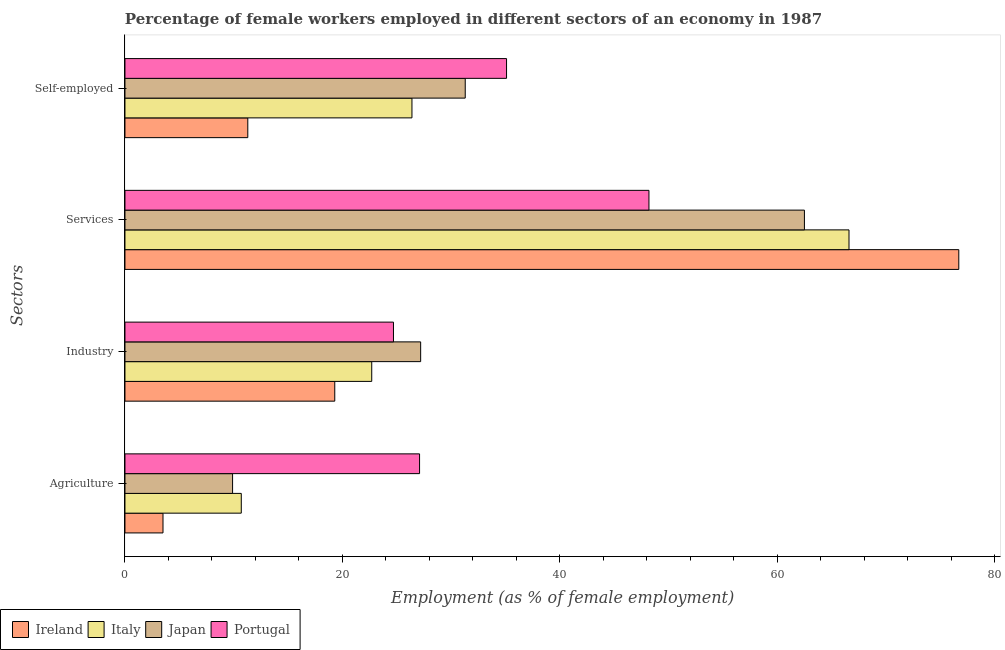Are the number of bars on each tick of the Y-axis equal?
Offer a very short reply. Yes. How many bars are there on the 1st tick from the top?
Keep it short and to the point. 4. What is the label of the 2nd group of bars from the top?
Offer a very short reply. Services. What is the percentage of female workers in agriculture in Japan?
Your answer should be compact. 9.9. Across all countries, what is the maximum percentage of female workers in services?
Ensure brevity in your answer.  76.7. Across all countries, what is the minimum percentage of female workers in agriculture?
Keep it short and to the point. 3.5. In which country was the percentage of self employed female workers minimum?
Ensure brevity in your answer.  Ireland. What is the total percentage of female workers in services in the graph?
Offer a very short reply. 254. What is the difference between the percentage of female workers in services in Ireland and that in Italy?
Your answer should be compact. 10.1. What is the difference between the percentage of female workers in industry in Ireland and the percentage of female workers in agriculture in Japan?
Make the answer very short. 9.4. What is the average percentage of female workers in agriculture per country?
Ensure brevity in your answer.  12.8. What is the difference between the percentage of self employed female workers and percentage of female workers in services in Japan?
Give a very brief answer. -31.2. What is the ratio of the percentage of self employed female workers in Italy to that in Ireland?
Your response must be concise. 2.34. Is the difference between the percentage of female workers in services in Japan and Ireland greater than the difference between the percentage of self employed female workers in Japan and Ireland?
Your answer should be compact. No. What is the difference between the highest and the second highest percentage of self employed female workers?
Ensure brevity in your answer.  3.8. What is the difference between the highest and the lowest percentage of female workers in agriculture?
Offer a very short reply. 23.6. What does the 2nd bar from the top in Self-employed represents?
Provide a short and direct response. Japan. What does the 2nd bar from the bottom in Industry represents?
Offer a terse response. Italy. Is it the case that in every country, the sum of the percentage of female workers in agriculture and percentage of female workers in industry is greater than the percentage of female workers in services?
Offer a very short reply. No. How many bars are there?
Your response must be concise. 16. Are the values on the major ticks of X-axis written in scientific E-notation?
Keep it short and to the point. No. Where does the legend appear in the graph?
Provide a short and direct response. Bottom left. How many legend labels are there?
Your answer should be compact. 4. How are the legend labels stacked?
Provide a succinct answer. Horizontal. What is the title of the graph?
Your response must be concise. Percentage of female workers employed in different sectors of an economy in 1987. What is the label or title of the X-axis?
Keep it short and to the point. Employment (as % of female employment). What is the label or title of the Y-axis?
Your answer should be compact. Sectors. What is the Employment (as % of female employment) of Italy in Agriculture?
Give a very brief answer. 10.7. What is the Employment (as % of female employment) of Japan in Agriculture?
Your answer should be very brief. 9.9. What is the Employment (as % of female employment) of Portugal in Agriculture?
Your answer should be very brief. 27.1. What is the Employment (as % of female employment) in Ireland in Industry?
Offer a very short reply. 19.3. What is the Employment (as % of female employment) of Italy in Industry?
Give a very brief answer. 22.7. What is the Employment (as % of female employment) of Japan in Industry?
Your answer should be compact. 27.2. What is the Employment (as % of female employment) of Portugal in Industry?
Your response must be concise. 24.7. What is the Employment (as % of female employment) of Ireland in Services?
Provide a succinct answer. 76.7. What is the Employment (as % of female employment) in Italy in Services?
Keep it short and to the point. 66.6. What is the Employment (as % of female employment) of Japan in Services?
Provide a succinct answer. 62.5. What is the Employment (as % of female employment) of Portugal in Services?
Make the answer very short. 48.2. What is the Employment (as % of female employment) in Ireland in Self-employed?
Make the answer very short. 11.3. What is the Employment (as % of female employment) in Italy in Self-employed?
Your answer should be compact. 26.4. What is the Employment (as % of female employment) in Japan in Self-employed?
Your answer should be very brief. 31.3. What is the Employment (as % of female employment) of Portugal in Self-employed?
Provide a succinct answer. 35.1. Across all Sectors, what is the maximum Employment (as % of female employment) in Ireland?
Your answer should be compact. 76.7. Across all Sectors, what is the maximum Employment (as % of female employment) of Italy?
Your answer should be very brief. 66.6. Across all Sectors, what is the maximum Employment (as % of female employment) of Japan?
Your response must be concise. 62.5. Across all Sectors, what is the maximum Employment (as % of female employment) in Portugal?
Keep it short and to the point. 48.2. Across all Sectors, what is the minimum Employment (as % of female employment) in Italy?
Your answer should be very brief. 10.7. Across all Sectors, what is the minimum Employment (as % of female employment) in Japan?
Provide a succinct answer. 9.9. Across all Sectors, what is the minimum Employment (as % of female employment) in Portugal?
Provide a short and direct response. 24.7. What is the total Employment (as % of female employment) in Ireland in the graph?
Keep it short and to the point. 110.8. What is the total Employment (as % of female employment) of Italy in the graph?
Offer a terse response. 126.4. What is the total Employment (as % of female employment) in Japan in the graph?
Offer a very short reply. 130.9. What is the total Employment (as % of female employment) in Portugal in the graph?
Give a very brief answer. 135.1. What is the difference between the Employment (as % of female employment) in Ireland in Agriculture and that in Industry?
Your response must be concise. -15.8. What is the difference between the Employment (as % of female employment) of Italy in Agriculture and that in Industry?
Keep it short and to the point. -12. What is the difference between the Employment (as % of female employment) in Japan in Agriculture and that in Industry?
Offer a terse response. -17.3. What is the difference between the Employment (as % of female employment) in Ireland in Agriculture and that in Services?
Keep it short and to the point. -73.2. What is the difference between the Employment (as % of female employment) of Italy in Agriculture and that in Services?
Ensure brevity in your answer.  -55.9. What is the difference between the Employment (as % of female employment) in Japan in Agriculture and that in Services?
Your answer should be very brief. -52.6. What is the difference between the Employment (as % of female employment) of Portugal in Agriculture and that in Services?
Offer a terse response. -21.1. What is the difference between the Employment (as % of female employment) in Italy in Agriculture and that in Self-employed?
Ensure brevity in your answer.  -15.7. What is the difference between the Employment (as % of female employment) in Japan in Agriculture and that in Self-employed?
Give a very brief answer. -21.4. What is the difference between the Employment (as % of female employment) of Portugal in Agriculture and that in Self-employed?
Your response must be concise. -8. What is the difference between the Employment (as % of female employment) of Ireland in Industry and that in Services?
Offer a terse response. -57.4. What is the difference between the Employment (as % of female employment) of Italy in Industry and that in Services?
Give a very brief answer. -43.9. What is the difference between the Employment (as % of female employment) in Japan in Industry and that in Services?
Provide a succinct answer. -35.3. What is the difference between the Employment (as % of female employment) of Portugal in Industry and that in Services?
Ensure brevity in your answer.  -23.5. What is the difference between the Employment (as % of female employment) of Japan in Industry and that in Self-employed?
Offer a very short reply. -4.1. What is the difference between the Employment (as % of female employment) of Ireland in Services and that in Self-employed?
Your answer should be compact. 65.4. What is the difference between the Employment (as % of female employment) in Italy in Services and that in Self-employed?
Make the answer very short. 40.2. What is the difference between the Employment (as % of female employment) in Japan in Services and that in Self-employed?
Your response must be concise. 31.2. What is the difference between the Employment (as % of female employment) of Portugal in Services and that in Self-employed?
Give a very brief answer. 13.1. What is the difference between the Employment (as % of female employment) in Ireland in Agriculture and the Employment (as % of female employment) in Italy in Industry?
Provide a succinct answer. -19.2. What is the difference between the Employment (as % of female employment) of Ireland in Agriculture and the Employment (as % of female employment) of Japan in Industry?
Give a very brief answer. -23.7. What is the difference between the Employment (as % of female employment) of Ireland in Agriculture and the Employment (as % of female employment) of Portugal in Industry?
Keep it short and to the point. -21.2. What is the difference between the Employment (as % of female employment) in Italy in Agriculture and the Employment (as % of female employment) in Japan in Industry?
Offer a terse response. -16.5. What is the difference between the Employment (as % of female employment) of Japan in Agriculture and the Employment (as % of female employment) of Portugal in Industry?
Give a very brief answer. -14.8. What is the difference between the Employment (as % of female employment) in Ireland in Agriculture and the Employment (as % of female employment) in Italy in Services?
Your response must be concise. -63.1. What is the difference between the Employment (as % of female employment) in Ireland in Agriculture and the Employment (as % of female employment) in Japan in Services?
Your response must be concise. -59. What is the difference between the Employment (as % of female employment) in Ireland in Agriculture and the Employment (as % of female employment) in Portugal in Services?
Your response must be concise. -44.7. What is the difference between the Employment (as % of female employment) in Italy in Agriculture and the Employment (as % of female employment) in Japan in Services?
Provide a succinct answer. -51.8. What is the difference between the Employment (as % of female employment) in Italy in Agriculture and the Employment (as % of female employment) in Portugal in Services?
Your response must be concise. -37.5. What is the difference between the Employment (as % of female employment) in Japan in Agriculture and the Employment (as % of female employment) in Portugal in Services?
Your answer should be compact. -38.3. What is the difference between the Employment (as % of female employment) of Ireland in Agriculture and the Employment (as % of female employment) of Italy in Self-employed?
Provide a succinct answer. -22.9. What is the difference between the Employment (as % of female employment) of Ireland in Agriculture and the Employment (as % of female employment) of Japan in Self-employed?
Your answer should be very brief. -27.8. What is the difference between the Employment (as % of female employment) of Ireland in Agriculture and the Employment (as % of female employment) of Portugal in Self-employed?
Offer a very short reply. -31.6. What is the difference between the Employment (as % of female employment) in Italy in Agriculture and the Employment (as % of female employment) in Japan in Self-employed?
Offer a terse response. -20.6. What is the difference between the Employment (as % of female employment) in Italy in Agriculture and the Employment (as % of female employment) in Portugal in Self-employed?
Your response must be concise. -24.4. What is the difference between the Employment (as % of female employment) of Japan in Agriculture and the Employment (as % of female employment) of Portugal in Self-employed?
Provide a succinct answer. -25.2. What is the difference between the Employment (as % of female employment) of Ireland in Industry and the Employment (as % of female employment) of Italy in Services?
Ensure brevity in your answer.  -47.3. What is the difference between the Employment (as % of female employment) in Ireland in Industry and the Employment (as % of female employment) in Japan in Services?
Offer a terse response. -43.2. What is the difference between the Employment (as % of female employment) of Ireland in Industry and the Employment (as % of female employment) of Portugal in Services?
Your answer should be compact. -28.9. What is the difference between the Employment (as % of female employment) in Italy in Industry and the Employment (as % of female employment) in Japan in Services?
Keep it short and to the point. -39.8. What is the difference between the Employment (as % of female employment) in Italy in Industry and the Employment (as % of female employment) in Portugal in Services?
Keep it short and to the point. -25.5. What is the difference between the Employment (as % of female employment) in Ireland in Industry and the Employment (as % of female employment) in Portugal in Self-employed?
Offer a terse response. -15.8. What is the difference between the Employment (as % of female employment) in Italy in Industry and the Employment (as % of female employment) in Portugal in Self-employed?
Your response must be concise. -12.4. What is the difference between the Employment (as % of female employment) of Ireland in Services and the Employment (as % of female employment) of Italy in Self-employed?
Your answer should be compact. 50.3. What is the difference between the Employment (as % of female employment) of Ireland in Services and the Employment (as % of female employment) of Japan in Self-employed?
Provide a succinct answer. 45.4. What is the difference between the Employment (as % of female employment) in Ireland in Services and the Employment (as % of female employment) in Portugal in Self-employed?
Ensure brevity in your answer.  41.6. What is the difference between the Employment (as % of female employment) in Italy in Services and the Employment (as % of female employment) in Japan in Self-employed?
Provide a short and direct response. 35.3. What is the difference between the Employment (as % of female employment) in Italy in Services and the Employment (as % of female employment) in Portugal in Self-employed?
Provide a short and direct response. 31.5. What is the difference between the Employment (as % of female employment) of Japan in Services and the Employment (as % of female employment) of Portugal in Self-employed?
Give a very brief answer. 27.4. What is the average Employment (as % of female employment) in Ireland per Sectors?
Provide a short and direct response. 27.7. What is the average Employment (as % of female employment) of Italy per Sectors?
Make the answer very short. 31.6. What is the average Employment (as % of female employment) in Japan per Sectors?
Your response must be concise. 32.73. What is the average Employment (as % of female employment) of Portugal per Sectors?
Make the answer very short. 33.77. What is the difference between the Employment (as % of female employment) of Ireland and Employment (as % of female employment) of Italy in Agriculture?
Offer a terse response. -7.2. What is the difference between the Employment (as % of female employment) of Ireland and Employment (as % of female employment) of Japan in Agriculture?
Offer a very short reply. -6.4. What is the difference between the Employment (as % of female employment) in Ireland and Employment (as % of female employment) in Portugal in Agriculture?
Make the answer very short. -23.6. What is the difference between the Employment (as % of female employment) in Italy and Employment (as % of female employment) in Portugal in Agriculture?
Your response must be concise. -16.4. What is the difference between the Employment (as % of female employment) in Japan and Employment (as % of female employment) in Portugal in Agriculture?
Offer a terse response. -17.2. What is the difference between the Employment (as % of female employment) in Ireland and Employment (as % of female employment) in Italy in Industry?
Give a very brief answer. -3.4. What is the difference between the Employment (as % of female employment) in Japan and Employment (as % of female employment) in Portugal in Industry?
Offer a very short reply. 2.5. What is the difference between the Employment (as % of female employment) of Italy and Employment (as % of female employment) of Japan in Services?
Make the answer very short. 4.1. What is the difference between the Employment (as % of female employment) in Italy and Employment (as % of female employment) in Portugal in Services?
Ensure brevity in your answer.  18.4. What is the difference between the Employment (as % of female employment) of Japan and Employment (as % of female employment) of Portugal in Services?
Give a very brief answer. 14.3. What is the difference between the Employment (as % of female employment) in Ireland and Employment (as % of female employment) in Italy in Self-employed?
Provide a succinct answer. -15.1. What is the difference between the Employment (as % of female employment) in Ireland and Employment (as % of female employment) in Japan in Self-employed?
Make the answer very short. -20. What is the difference between the Employment (as % of female employment) in Ireland and Employment (as % of female employment) in Portugal in Self-employed?
Keep it short and to the point. -23.8. What is the difference between the Employment (as % of female employment) in Italy and Employment (as % of female employment) in Japan in Self-employed?
Provide a succinct answer. -4.9. What is the difference between the Employment (as % of female employment) of Italy and Employment (as % of female employment) of Portugal in Self-employed?
Offer a terse response. -8.7. What is the difference between the Employment (as % of female employment) of Japan and Employment (as % of female employment) of Portugal in Self-employed?
Your answer should be very brief. -3.8. What is the ratio of the Employment (as % of female employment) of Ireland in Agriculture to that in Industry?
Ensure brevity in your answer.  0.18. What is the ratio of the Employment (as % of female employment) in Italy in Agriculture to that in Industry?
Provide a succinct answer. 0.47. What is the ratio of the Employment (as % of female employment) in Japan in Agriculture to that in Industry?
Keep it short and to the point. 0.36. What is the ratio of the Employment (as % of female employment) in Portugal in Agriculture to that in Industry?
Your answer should be compact. 1.1. What is the ratio of the Employment (as % of female employment) in Ireland in Agriculture to that in Services?
Your response must be concise. 0.05. What is the ratio of the Employment (as % of female employment) of Italy in Agriculture to that in Services?
Offer a very short reply. 0.16. What is the ratio of the Employment (as % of female employment) of Japan in Agriculture to that in Services?
Your response must be concise. 0.16. What is the ratio of the Employment (as % of female employment) of Portugal in Agriculture to that in Services?
Provide a succinct answer. 0.56. What is the ratio of the Employment (as % of female employment) in Ireland in Agriculture to that in Self-employed?
Keep it short and to the point. 0.31. What is the ratio of the Employment (as % of female employment) in Italy in Agriculture to that in Self-employed?
Offer a terse response. 0.41. What is the ratio of the Employment (as % of female employment) in Japan in Agriculture to that in Self-employed?
Offer a very short reply. 0.32. What is the ratio of the Employment (as % of female employment) in Portugal in Agriculture to that in Self-employed?
Ensure brevity in your answer.  0.77. What is the ratio of the Employment (as % of female employment) in Ireland in Industry to that in Services?
Offer a very short reply. 0.25. What is the ratio of the Employment (as % of female employment) in Italy in Industry to that in Services?
Your answer should be very brief. 0.34. What is the ratio of the Employment (as % of female employment) in Japan in Industry to that in Services?
Offer a very short reply. 0.44. What is the ratio of the Employment (as % of female employment) of Portugal in Industry to that in Services?
Offer a terse response. 0.51. What is the ratio of the Employment (as % of female employment) of Ireland in Industry to that in Self-employed?
Give a very brief answer. 1.71. What is the ratio of the Employment (as % of female employment) in Italy in Industry to that in Self-employed?
Offer a terse response. 0.86. What is the ratio of the Employment (as % of female employment) in Japan in Industry to that in Self-employed?
Provide a short and direct response. 0.87. What is the ratio of the Employment (as % of female employment) in Portugal in Industry to that in Self-employed?
Provide a short and direct response. 0.7. What is the ratio of the Employment (as % of female employment) in Ireland in Services to that in Self-employed?
Keep it short and to the point. 6.79. What is the ratio of the Employment (as % of female employment) of Italy in Services to that in Self-employed?
Provide a succinct answer. 2.52. What is the ratio of the Employment (as % of female employment) in Japan in Services to that in Self-employed?
Give a very brief answer. 2. What is the ratio of the Employment (as % of female employment) of Portugal in Services to that in Self-employed?
Your response must be concise. 1.37. What is the difference between the highest and the second highest Employment (as % of female employment) in Ireland?
Keep it short and to the point. 57.4. What is the difference between the highest and the second highest Employment (as % of female employment) of Italy?
Provide a short and direct response. 40.2. What is the difference between the highest and the second highest Employment (as % of female employment) of Japan?
Offer a terse response. 31.2. What is the difference between the highest and the lowest Employment (as % of female employment) of Ireland?
Offer a terse response. 73.2. What is the difference between the highest and the lowest Employment (as % of female employment) of Italy?
Offer a very short reply. 55.9. What is the difference between the highest and the lowest Employment (as % of female employment) of Japan?
Provide a succinct answer. 52.6. What is the difference between the highest and the lowest Employment (as % of female employment) in Portugal?
Make the answer very short. 23.5. 